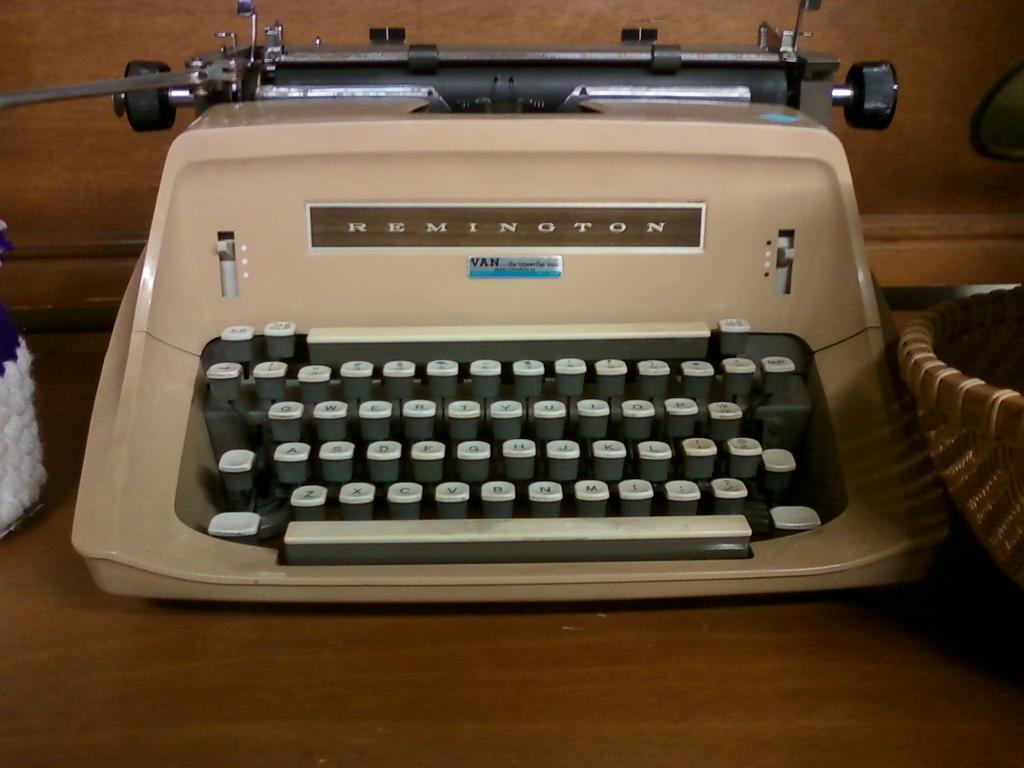In one or two sentences, can you explain what this image depicts? In the picture there is a table, on the table there is a typing machine, beside the typing machine there may be a basket, behind there is a wall. 